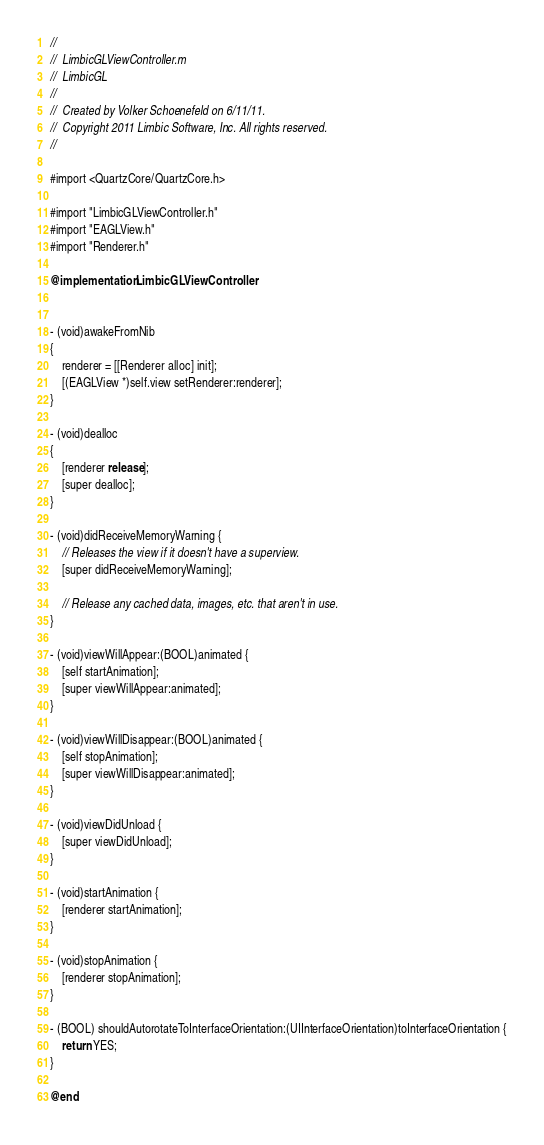<code> <loc_0><loc_0><loc_500><loc_500><_ObjectiveC_>//
//  LimbicGLViewController.m
//  LimbicGL
//
//  Created by Volker Schoenefeld on 6/11/11.
//  Copyright 2011 Limbic Software, Inc. All rights reserved.
//

#import <QuartzCore/QuartzCore.h>

#import "LimbicGLViewController.h"
#import "EAGLView.h"
#import "Renderer.h"

@implementation LimbicGLViewController


- (void)awakeFromNib
{
    renderer = [[Renderer alloc] init];
    [(EAGLView *)self.view setRenderer:renderer];
}

- (void)dealloc
{
    [renderer release];
    [super dealloc];
}

- (void)didReceiveMemoryWarning {
    // Releases the view if it doesn't have a superview.
    [super didReceiveMemoryWarning];
    
    // Release any cached data, images, etc. that aren't in use.
}

- (void)viewWillAppear:(BOOL)animated {
    [self startAnimation];
    [super viewWillAppear:animated];
}

- (void)viewWillDisappear:(BOOL)animated {
    [self stopAnimation];
    [super viewWillDisappear:animated];
}

- (void)viewDidUnload {
    [super viewDidUnload];
}

- (void)startAnimation {
    [renderer startAnimation];
}

- (void)stopAnimation {
    [renderer stopAnimation];
}

- (BOOL) shouldAutorotateToInterfaceOrientation:(UIInterfaceOrientation)toInterfaceOrientation {
    return YES;
}

@end
</code> 